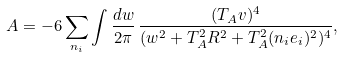Convert formula to latex. <formula><loc_0><loc_0><loc_500><loc_500>A = - 6 \sum _ { n _ { i } } \int \frac { d w } { 2 \pi } \, \frac { ( T _ { A } v ) ^ { 4 } } { ( w ^ { 2 } + T _ { A } ^ { 2 } R ^ { 2 } + T ^ { 2 } _ { A } ( n _ { i } e _ { i } ) ^ { 2 } ) ^ { 4 } } ,</formula> 